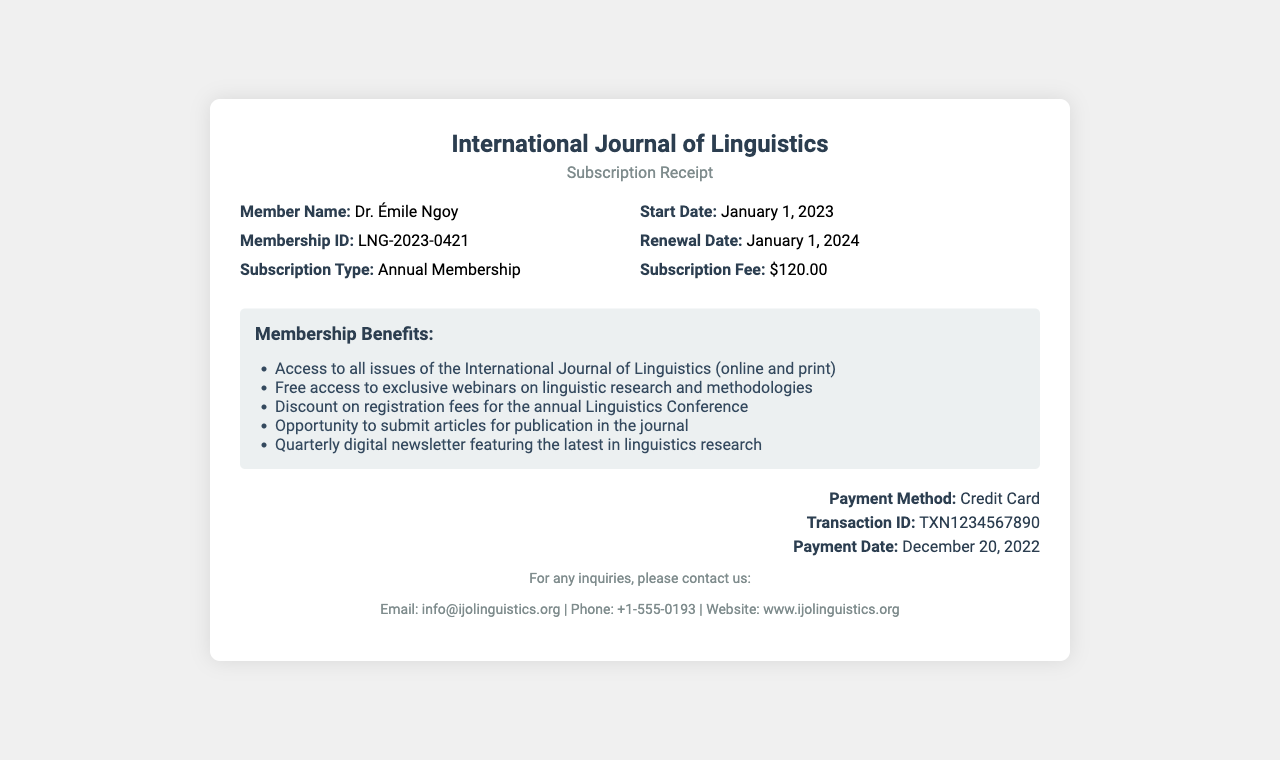What is the member name? The member name is specified in the receipt under the details section.
Answer: Dr. Émile Ngoy What is the membership ID? The membership ID is listed along with the member's name and subscription type.
Answer: LNG-2023-0421 What is the subscription fee? The subscription fee is explicitly stated in the details section of the receipt.
Answer: $120.00 When is the renewal date? The renewal date is mentioned in the details section and is a key part of membership information.
Answer: January 1, 2024 What are the benefits of membership? The benefits of membership are outlined in a dedicated section highlighting what members receive.
Answer: Access to all issues of the International Journal of Linguistics (online and print), Free access to exclusive webinars on linguistic research and methodologies, Discount on registration fees for the annual Linguistics Conference, Opportunity to submit articles for publication in the journal, Quarterly digital newsletter featuring the latest in linguistics research What is the payment method? The payment method is stated in the payment section at the bottom of the receipt.
Answer: Credit Card What is the transaction ID? The transaction ID can be found in the payment details and is important for tracking the payment.
Answer: TXN1234567890 What is the start date of the membership? The start date is mentioned alongside the renewal date in the details section.
Answer: January 1, 2023 What is the website for inquiries? The website for inquiries is listed in the contact section at the end of the receipt.
Answer: www.ijolinguistics.org 